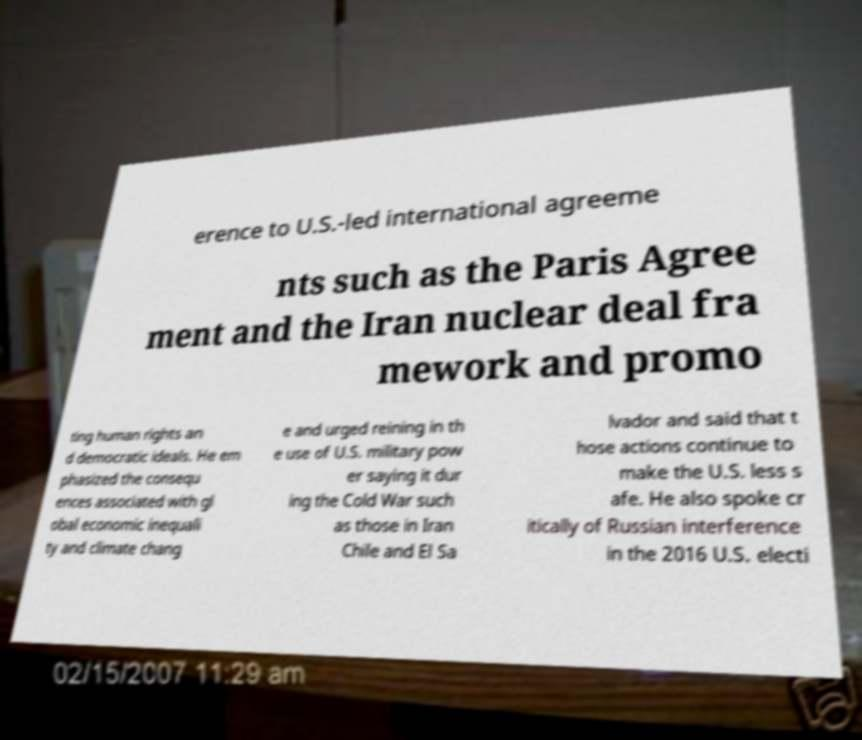Could you assist in decoding the text presented in this image and type it out clearly? erence to U.S.-led international agreeme nts such as the Paris Agree ment and the Iran nuclear deal fra mework and promo ting human rights an d democratic ideals. He em phasized the consequ ences associated with gl obal economic inequali ty and climate chang e and urged reining in th e use of U.S. military pow er saying it dur ing the Cold War such as those in Iran Chile and El Sa lvador and said that t hose actions continue to make the U.S. less s afe. He also spoke cr itically of Russian interference in the 2016 U.S. electi 